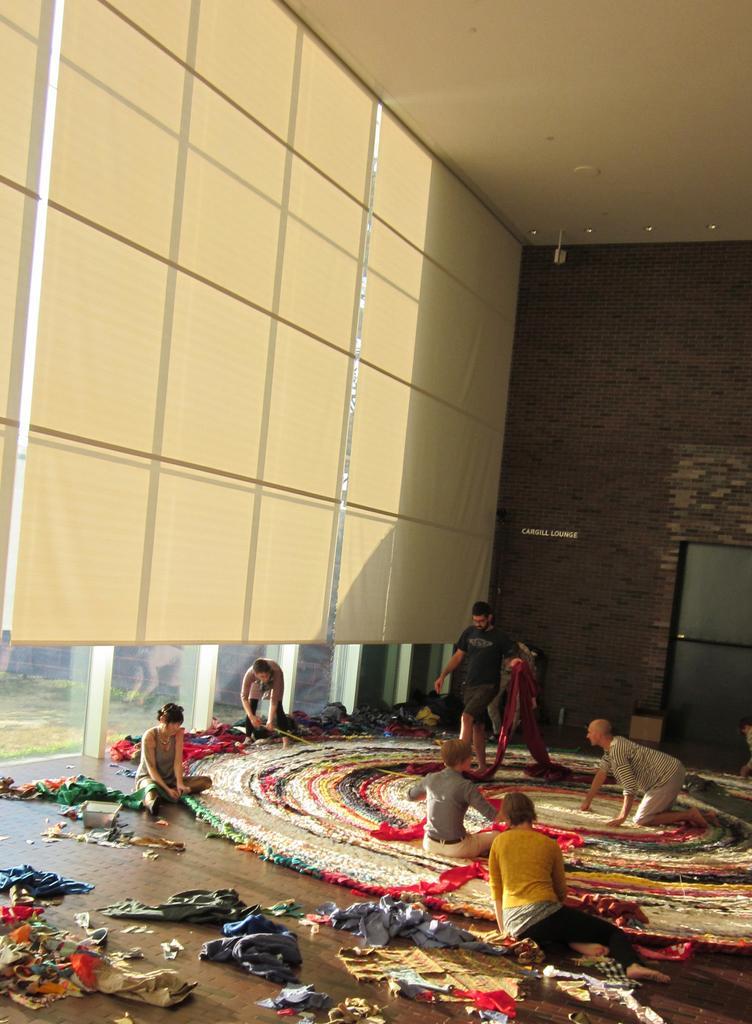How would you summarize this image in a sentence or two? In this image I can see group of people, some are sitting and some are walking and I can see few clothes in multi color, I can also see the window blind, few glass walls. Background the wall is in brown color. 